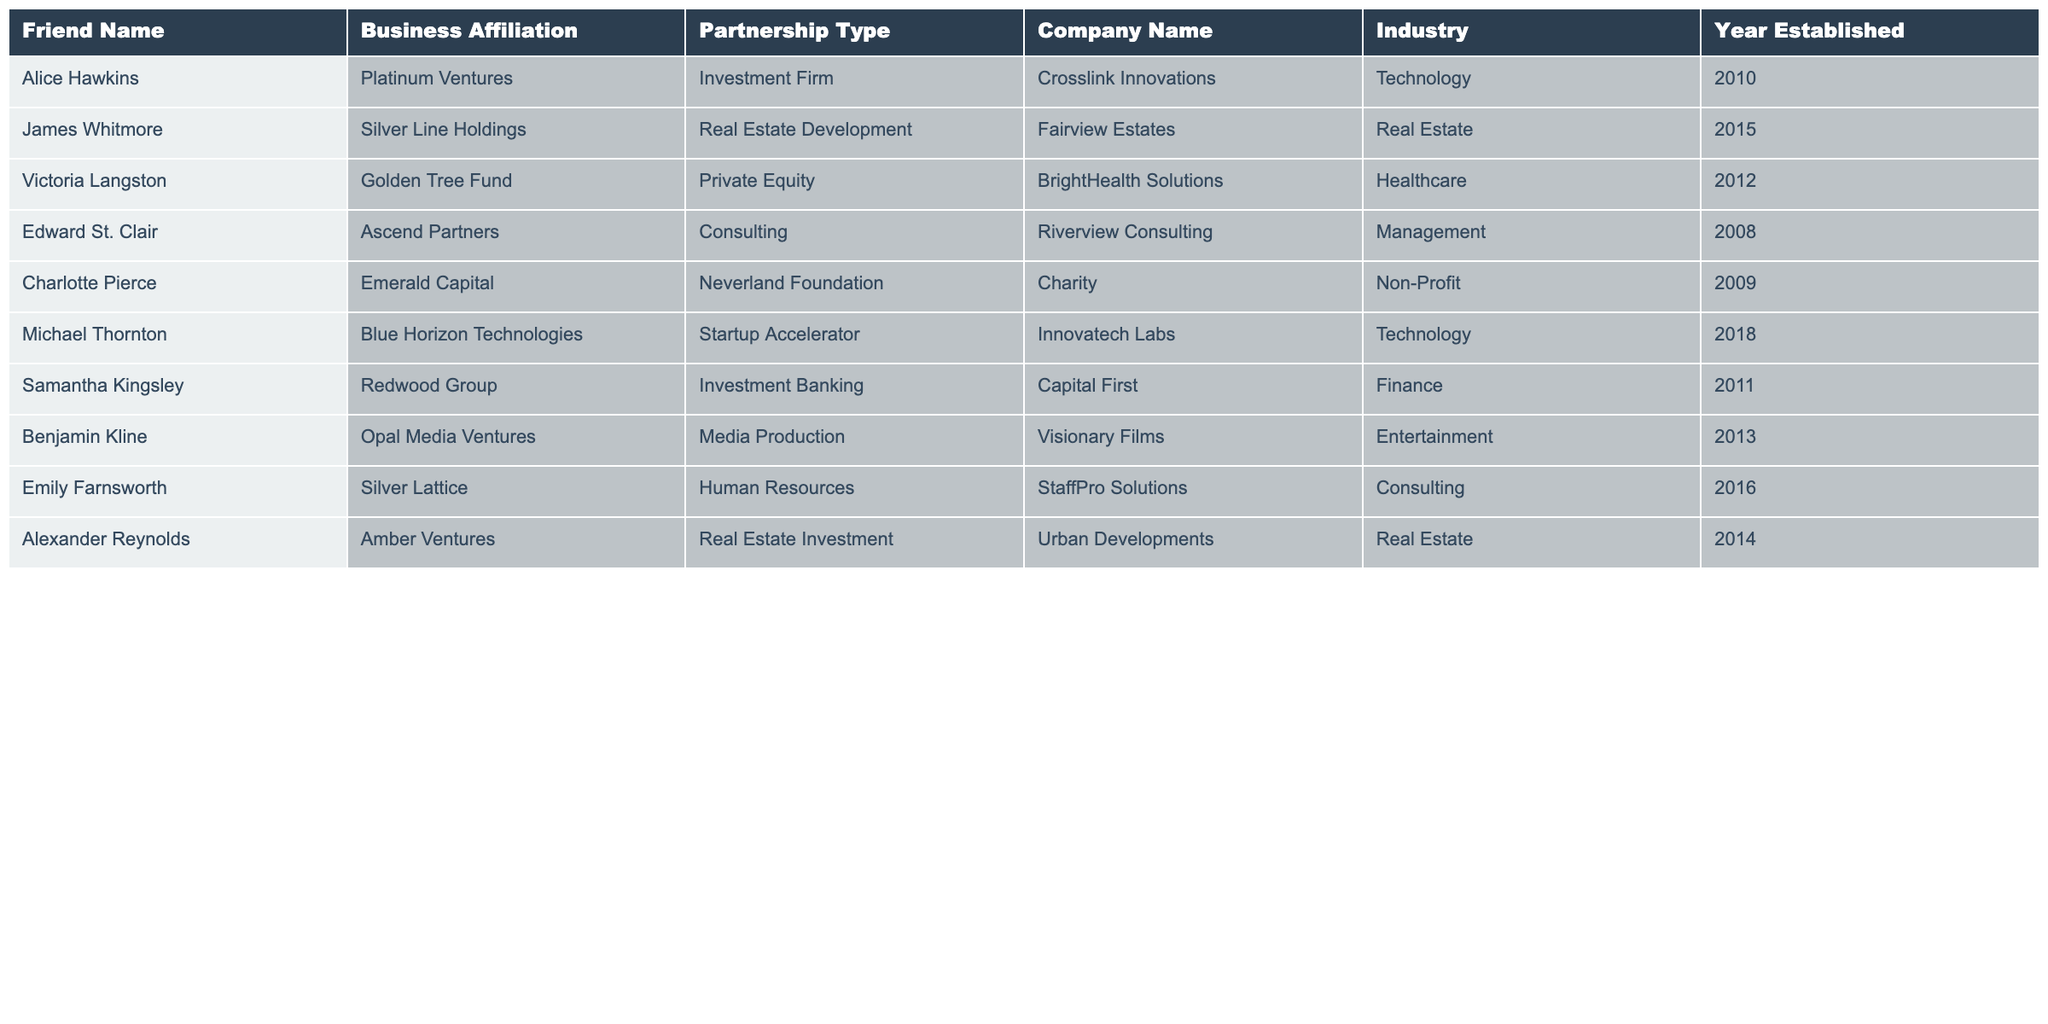What is the business affiliation of Victoria Langston? The table lists Victoria Langston's business affiliation as Golden Tree Fund.
Answer: Golden Tree Fund Which company is associated with Michael Thornton? According to the table, Michael Thornton is associated with Innovatech Labs.
Answer: Innovatech Labs How many friends are affiliated with the Real Estate industry? The table shows two friends affiliated with the Real Estate industry: James Whitmore and Alexander Reynolds.
Answer: 2 What year was the company BrightHealth Solutions established? The table indicates that BrightHealth Solutions was established in the year 2012.
Answer: 2012 Is Emily Farnsworth affiliated with an Investment Firm? The table states that Emily Farnsworth is affiliated with Silver Lattice, which is a Human Resources company, not an Investment Firm.
Answer: No Which friend has the longest established business partnership? By examining the table, Edward St. Clair's business affiliation with Riverview Consulting, established in 2008, is the earliest.
Answer: Edward St. Clair What industry does Charlotte Pierce's partnership belong to? The table shows that Charlotte Pierce's partnership with the Neverland Foundation is in the Non-Profit industry.
Answer: Non-Profit What is the average establishment year of the partnerships listed? Adding up the years (2010 + 2015 + 2012 + 2008 + 2009 + 2018 + 2011 + 2013 + 2014 + 2016) equals 2016, and dividing by 10 gives an average year of 2016.
Answer: 2016 Which friend's partnership was established most recently? Analyzing the table reveals that Michael Thornton's partnership with Innovatech Labs, established in 2018, is the most recent.
Answer: Michael Thornton Is there a friend who has a partnership that involves charitable contributions? Yes, Charlotte Pierce is affiliated with the Neverland Foundation, which is a charity.
Answer: Yes 